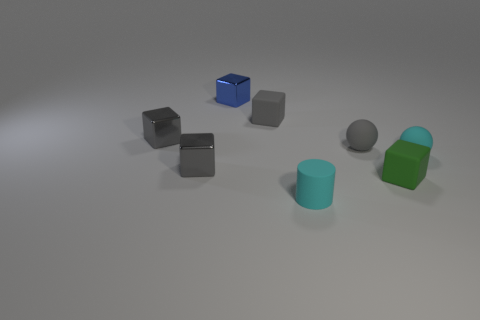There is another matte thing that is the same shape as the small green matte thing; what color is it?
Provide a short and direct response. Gray. How many shiny things are either big red spheres or gray spheres?
Your answer should be very brief. 0. There is a small metallic object in front of the tiny cyan object that is on the right side of the green matte thing; are there any green blocks on the left side of it?
Offer a very short reply. No. What is the color of the matte cylinder?
Keep it short and to the point. Cyan. Is the shape of the metal thing in front of the small cyan matte ball the same as  the tiny blue object?
Ensure brevity in your answer.  Yes. What number of objects are either small spheres or tiny cyan rubber things left of the small green block?
Offer a very short reply. 3. Does the small block that is to the right of the tiny cyan rubber cylinder have the same material as the blue cube?
Your answer should be compact. No. There is a gray object that is in front of the sphere right of the small gray sphere; what is its material?
Your answer should be very brief. Metal. Are there more tiny gray matte things that are right of the small cyan matte cylinder than rubber blocks behind the tiny blue block?
Make the answer very short. Yes. The gray rubber block has what size?
Offer a very short reply. Small. 